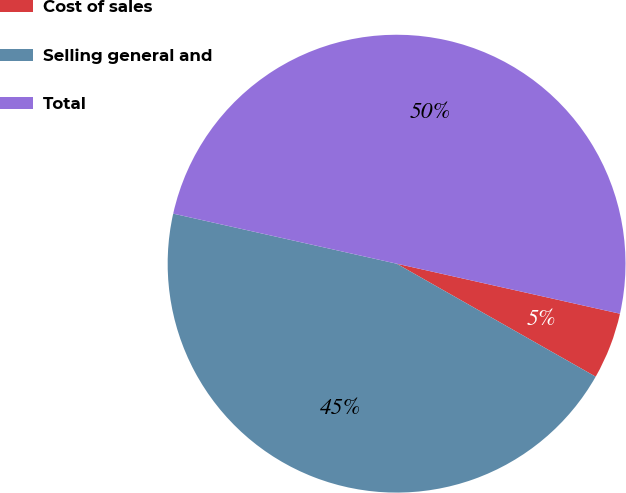Convert chart. <chart><loc_0><loc_0><loc_500><loc_500><pie_chart><fcel>Cost of sales<fcel>Selling general and<fcel>Total<nl><fcel>4.71%<fcel>45.29%<fcel>50.0%<nl></chart> 